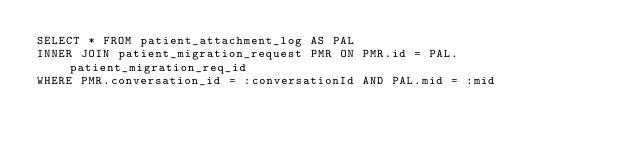<code> <loc_0><loc_0><loc_500><loc_500><_SQL_>SELECT * FROM patient_attachment_log AS PAL
INNER JOIN patient_migration_request PMR ON PMR.id = PAL.patient_migration_req_id
WHERE PMR.conversation_id = :conversationId AND PAL.mid = :mid</code> 